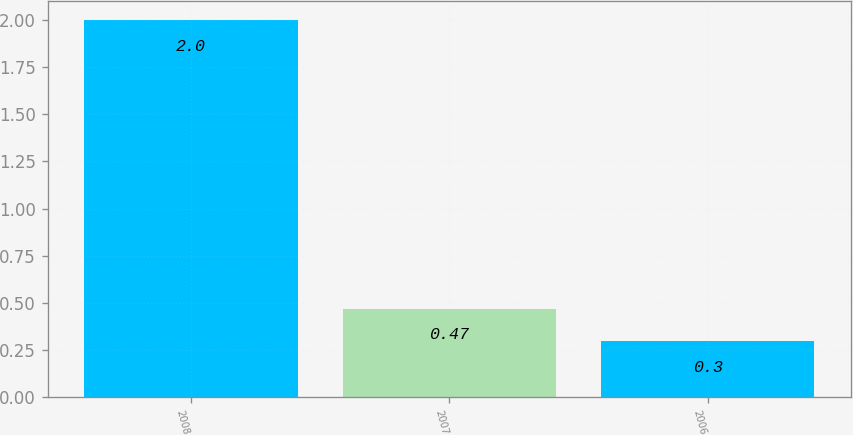Convert chart to OTSL. <chart><loc_0><loc_0><loc_500><loc_500><bar_chart><fcel>2008<fcel>2007<fcel>2006<nl><fcel>2<fcel>0.47<fcel>0.3<nl></chart> 